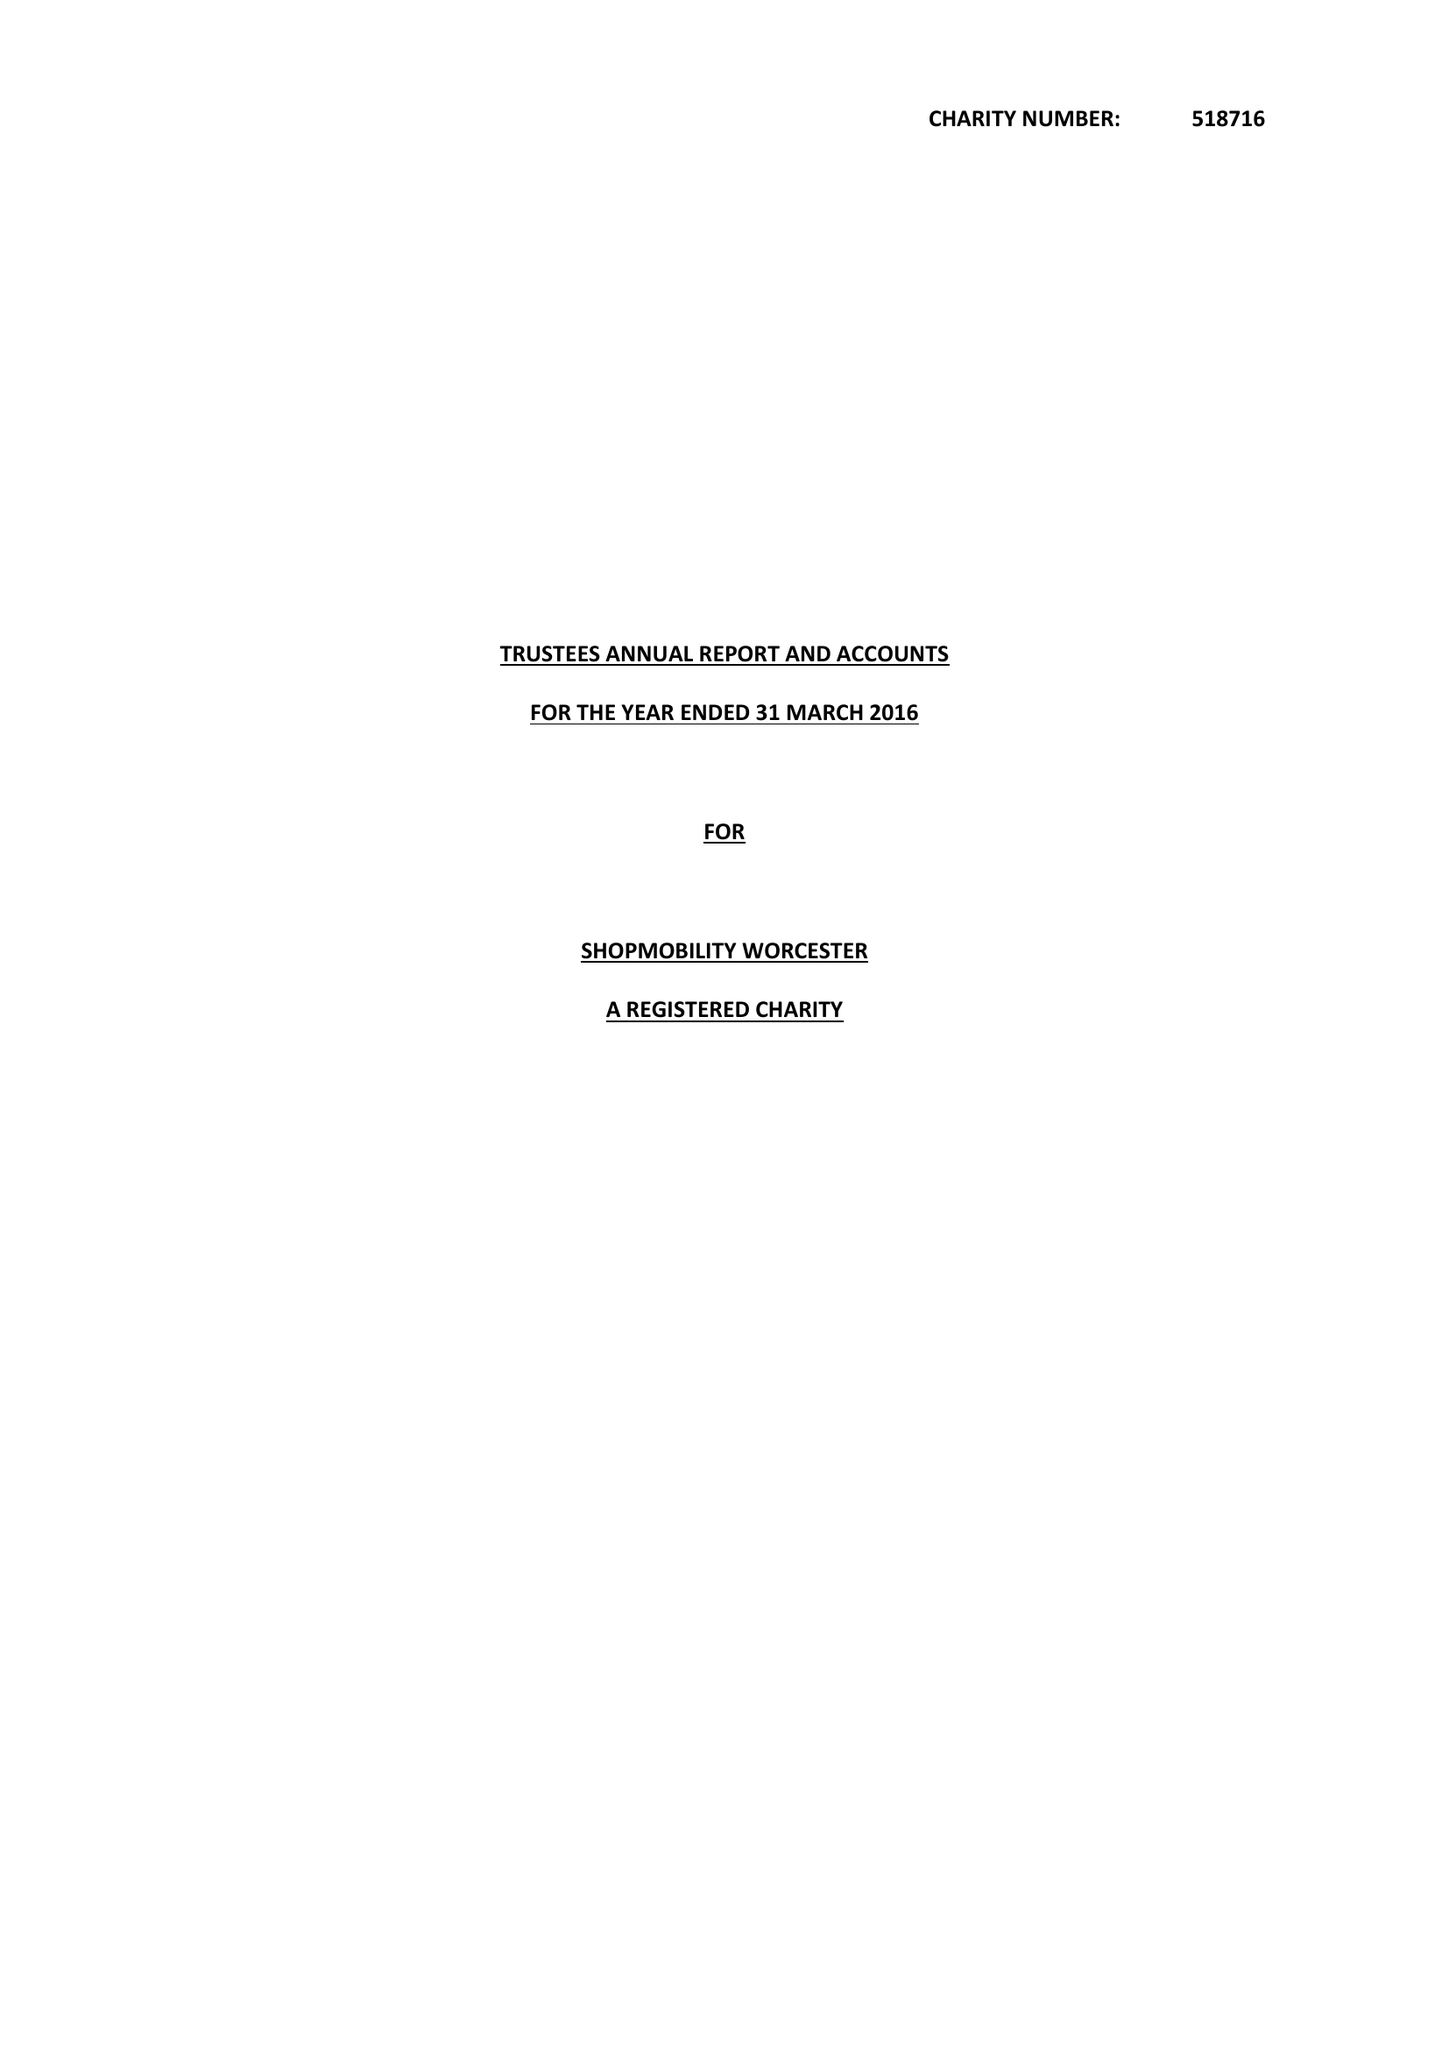What is the value for the spending_annually_in_british_pounds?
Answer the question using a single word or phrase. 24642.00 